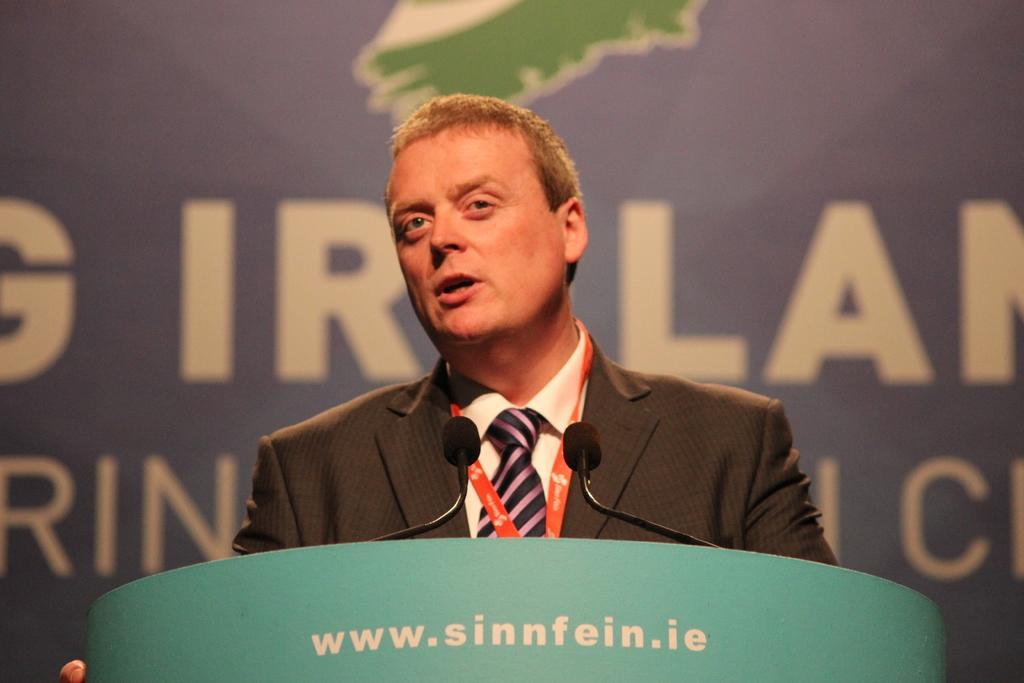Can you describe this image briefly? In this picture we can see a man in the blazer is standing behind the podium and on the podium there are microphones. Behind the person there is a board. 